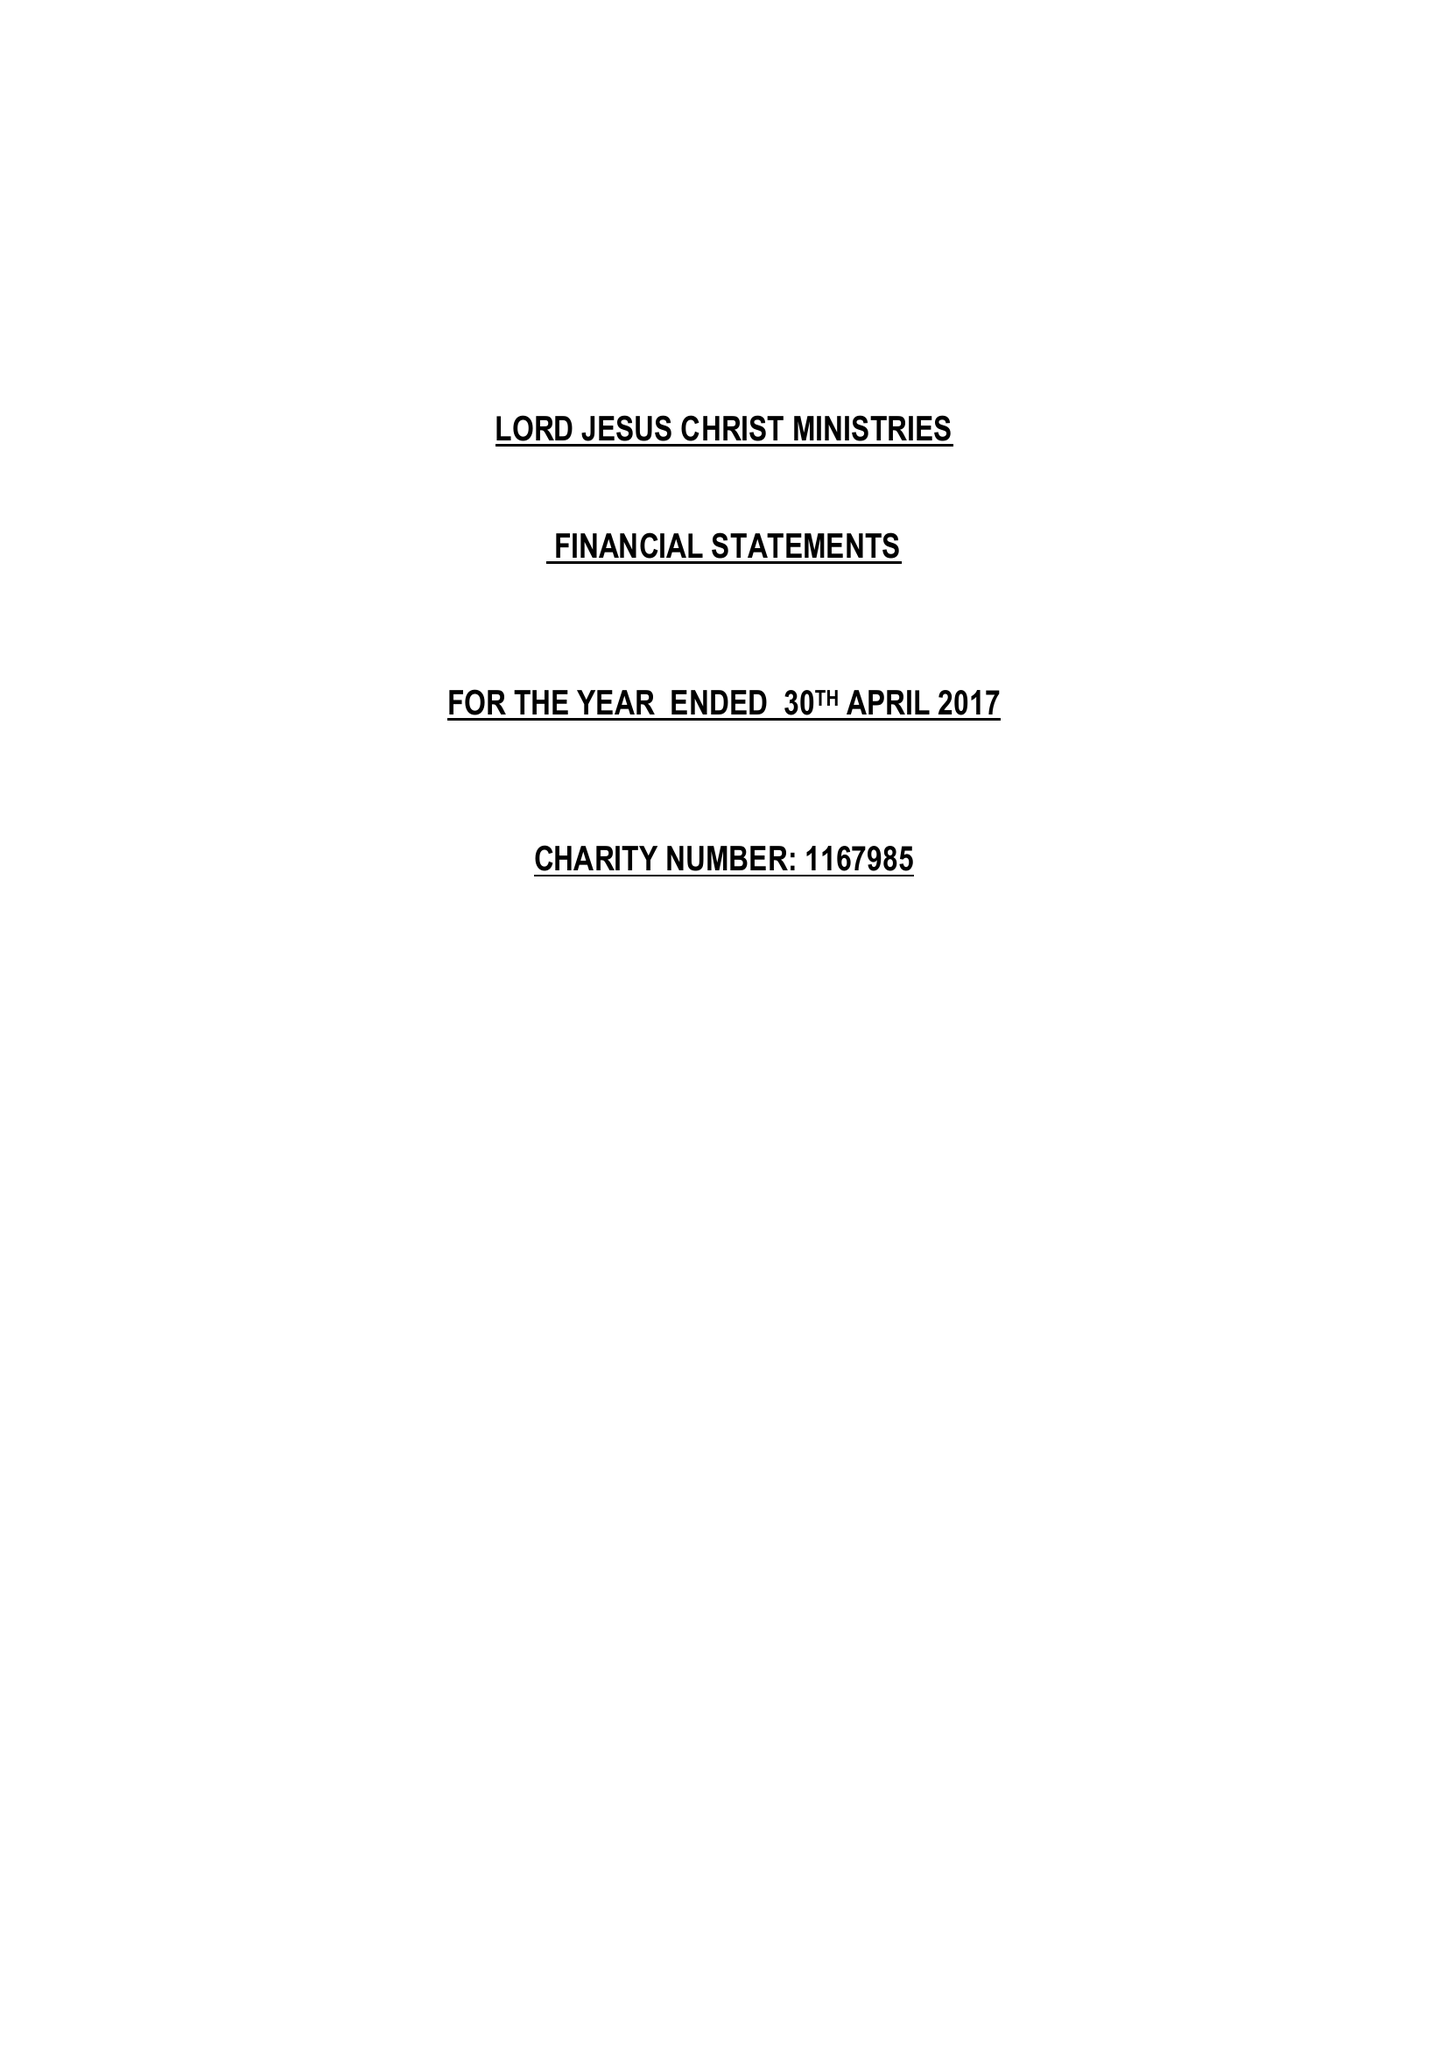What is the value for the charity_number?
Answer the question using a single word or phrase. 1167985 